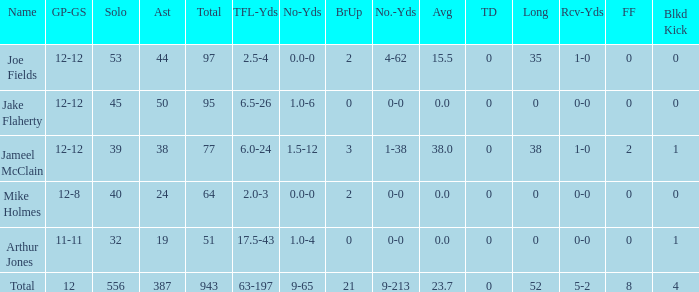How many yards for the player with tfl-yds of 2.5-4? 4-62. Could you help me parse every detail presented in this table? {'header': ['Name', 'GP-GS', 'Solo', 'Ast', 'Total', 'TFL-Yds', 'No-Yds', 'BrUp', 'No.-Yds', 'Avg', 'TD', 'Long', 'Rcv-Yds', 'FF', 'Blkd Kick'], 'rows': [['Joe Fields', '12-12', '53', '44', '97', '2.5-4', '0.0-0', '2', '4-62', '15.5', '0', '35', '1-0', '0', '0'], ['Jake Flaherty', '12-12', '45', '50', '95', '6.5-26', '1.0-6', '0', '0-0', '0.0', '0', '0', '0-0', '0', '0'], ['Jameel McClain', '12-12', '39', '38', '77', '6.0-24', '1.5-12', '3', '1-38', '38.0', '0', '38', '1-0', '2', '1'], ['Mike Holmes', '12-8', '40', '24', '64', '2.0-3', '0.0-0', '2', '0-0', '0.0', '0', '0', '0-0', '0', '0'], ['Arthur Jones', '11-11', '32', '19', '51', '17.5-43', '1.0-4', '0', '0-0', '0.0', '0', '0', '0-0', '0', '1'], ['Total', '12', '556', '387', '943', '63-197', '9-65', '21', '9-213', '23.7', '0', '52', '5-2', '8', '4']]} 